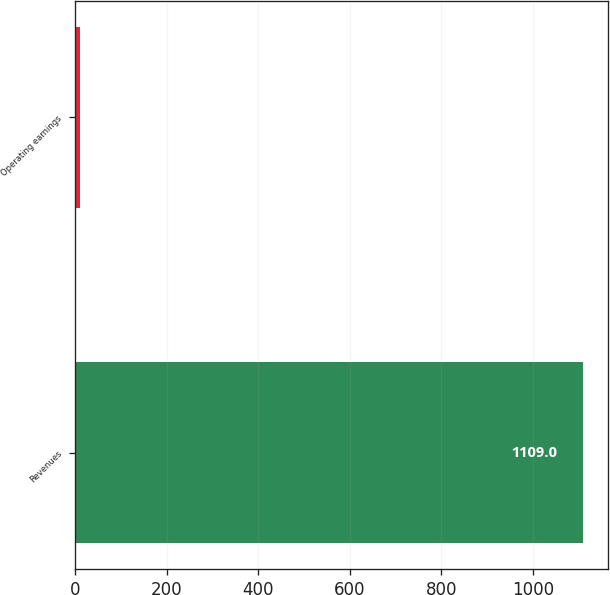Convert chart to OTSL. <chart><loc_0><loc_0><loc_500><loc_500><bar_chart><fcel>Revenues<fcel>Operating earnings<nl><fcel>1109<fcel>10<nl></chart> 